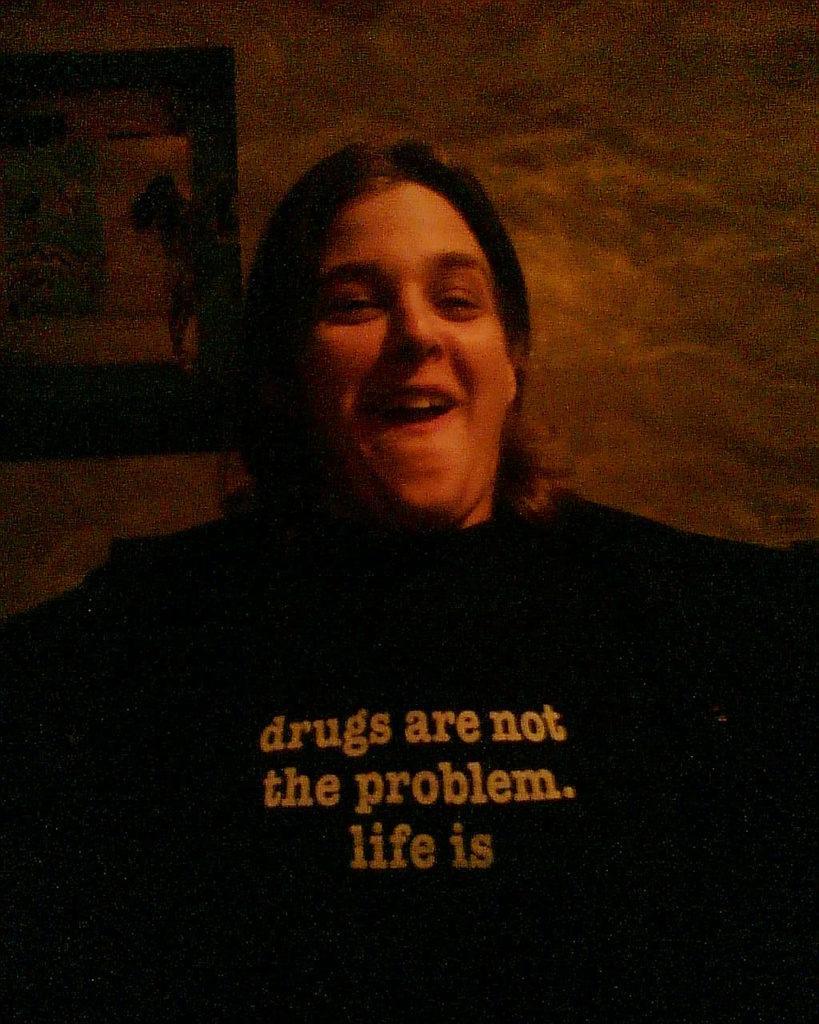In one or two sentences, can you explain what this image depicts? In this image I can see the person is wearing black color dress. I can see few objects and the dark background. 